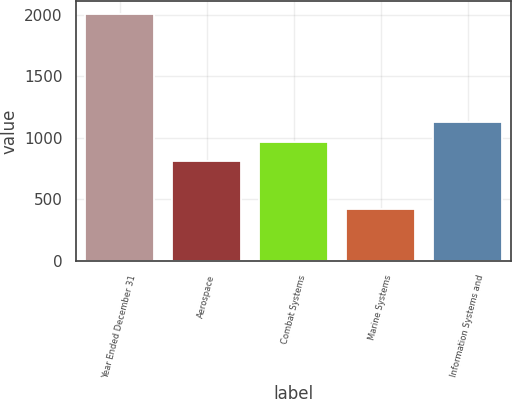Convert chart. <chart><loc_0><loc_0><loc_500><loc_500><bar_chart><fcel>Year Ended December 31<fcel>Aerospace<fcel>Combat Systems<fcel>Marine Systems<fcel>Information Systems and<nl><fcel>2007<fcel>810<fcel>968.6<fcel>421<fcel>1127.2<nl></chart> 